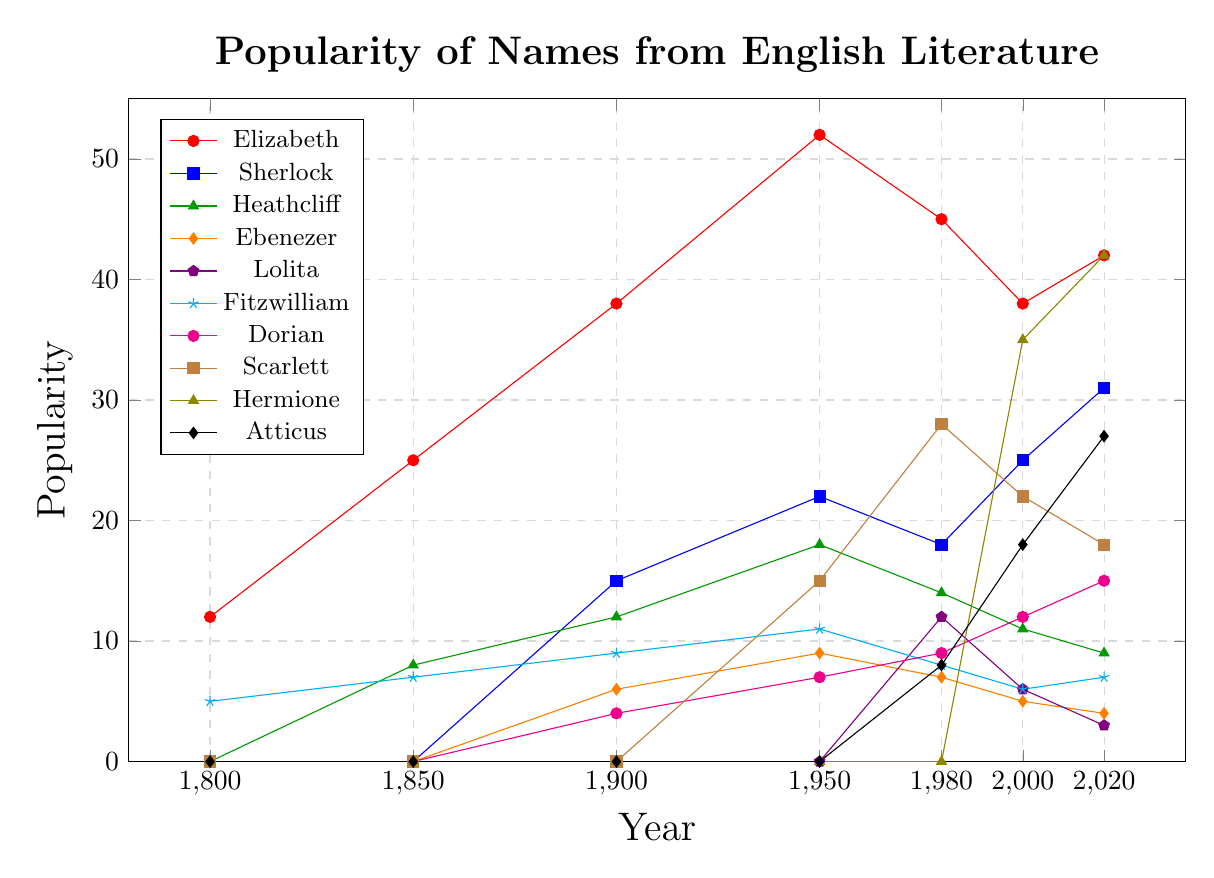What name was the most popular in 2020? To find the most popular name in 2020, look at the heights of all the lines at the 2020 mark. Compare the values associated with each line.
Answer: Hermione Which name had the highest increase in popularity between 1800 and 1950? Calculate the increase for each name from 1800 to 1950 by subtracting the 1800 value from the 1950 value for each name, then compare these increases. Elizabeth went from 12 to 52, Sherlock from 0 to 22, Heathcliff from 0 to 18, etc. Elizabeth has the highest increase.
Answer: Elizabeth How did the popularity of Hermione change between 2000 and 2020? Find the values for Hermione in 2000 and 2020. Hermione’s popularity was 35 in 2000 and increased to 42 in 2020.
Answer: Increased by 7 Which names appeared for the first time after 1900? Identify the lines that have a value of zero up to 1900 and then have non-zero values afterward. Sherlock, Lolita, Scarlett, Hermione, and Atticus fit this criterion.
Answer: Sherlock, Lolita, Scarlett, Hermione, Atticus What is the average popularity of 'Elizabeth' from 1850 to 2020? Values for Elizabeth from 1850 to 2020 are 25, 38, 52, 45, 38, 42. Sum these values and divide by the number of years (6). (25 + 38 + 52 + 45 + 38 + 42) / 6 = 40
Answer: 40 Which character’s name showed a decline in popularity from 2000 to 2020? Compare the values for each name in 2000 and 2020. A decline means the 2020 value is less than the 2000 value. For example, Elizabeth declined from 38 to 42, etc. Look for such declines.
Answer: Lolita, Scarlett, and Heathcliff Between Sherlock and Heathcliff, which name was more popular in 1980? Look at the 1980 data points for both names. Sherlock has a value of 18 and Heathcliff has 14. Sherlock is more popular.
Answer: Sherlock In which year did Scarlett reach its peak popularity? Locate the highest value for Scarlett across all years and note the corresponding year. For Scarlett, the peak value is 28 in 1980.
Answer: 1980 How many names were more popular than Fitzwilliam in 1950? Compare Fitzwilliam’s 1950 value (11) to the other names’ values in the same year. Count the names with higher values: Elizabeth (52), Sherlock (22), Heathcliff (18), Scarlett (15) makes it three names.
Answer: 3 What is the sum of the popularity of Atticus and Hermione in 2020? Add the popularity values of Hermione (42) and Atticus (27) for the year 2020. 42 + 27 = 69
Answer: 69 